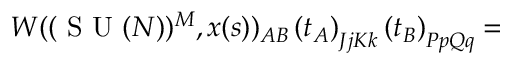Convert formula to latex. <formula><loc_0><loc_0><loc_500><loc_500>W ( ( S U ( N ) ) ^ { M } , x ( s ) ) _ { A B } \left ( t _ { A } \right ) _ { J j K k } \left ( t _ { B } \right ) _ { P p Q q } =</formula> 